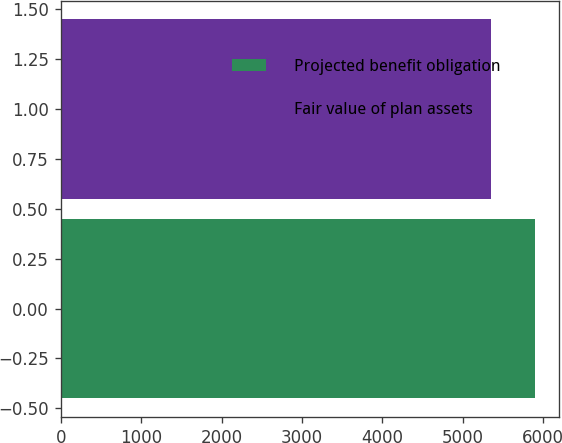Convert chart to OTSL. <chart><loc_0><loc_0><loc_500><loc_500><bar_chart><fcel>Projected benefit obligation<fcel>Fair value of plan assets<nl><fcel>5900.1<fcel>5357<nl></chart> 